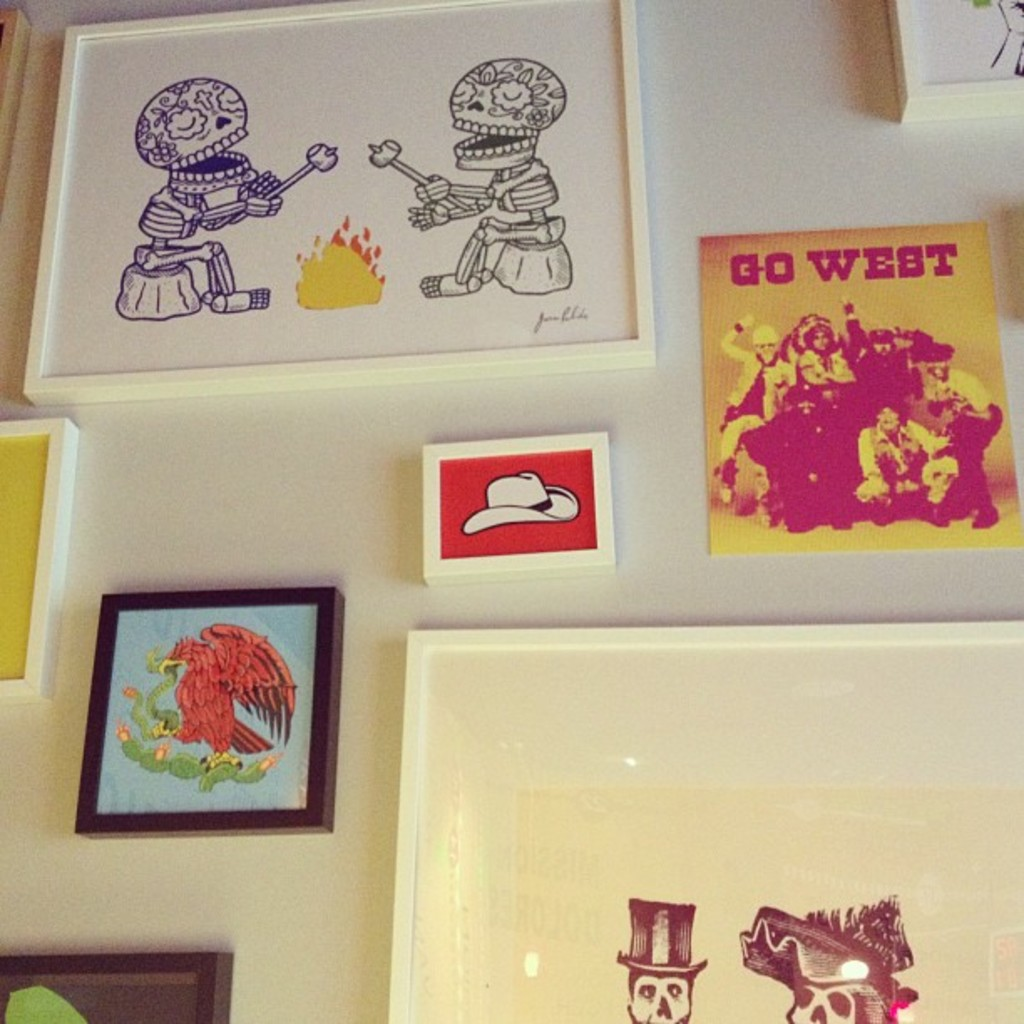Provide a one-sentence caption for the provided image. The image showcases a vibrant collection of quirky and colorful artworks, including a distinctive piece titled 'GO WEST' that features bold yellow and red tones, further accompanied by various other eccentric and visually engaging pieces like skeletal figures by a campfire and a red phoenix. 